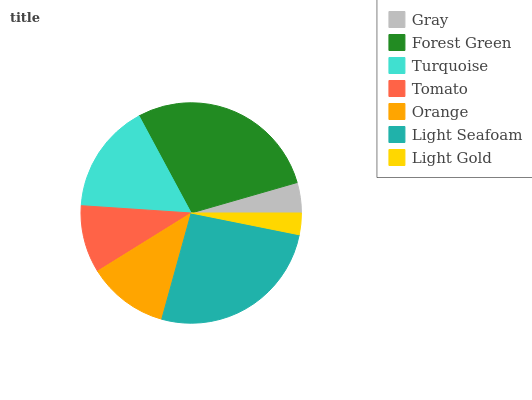Is Light Gold the minimum?
Answer yes or no. Yes. Is Forest Green the maximum?
Answer yes or no. Yes. Is Turquoise the minimum?
Answer yes or no. No. Is Turquoise the maximum?
Answer yes or no. No. Is Forest Green greater than Turquoise?
Answer yes or no. Yes. Is Turquoise less than Forest Green?
Answer yes or no. Yes. Is Turquoise greater than Forest Green?
Answer yes or no. No. Is Forest Green less than Turquoise?
Answer yes or no. No. Is Orange the high median?
Answer yes or no. Yes. Is Orange the low median?
Answer yes or no. Yes. Is Light Seafoam the high median?
Answer yes or no. No. Is Light Gold the low median?
Answer yes or no. No. 